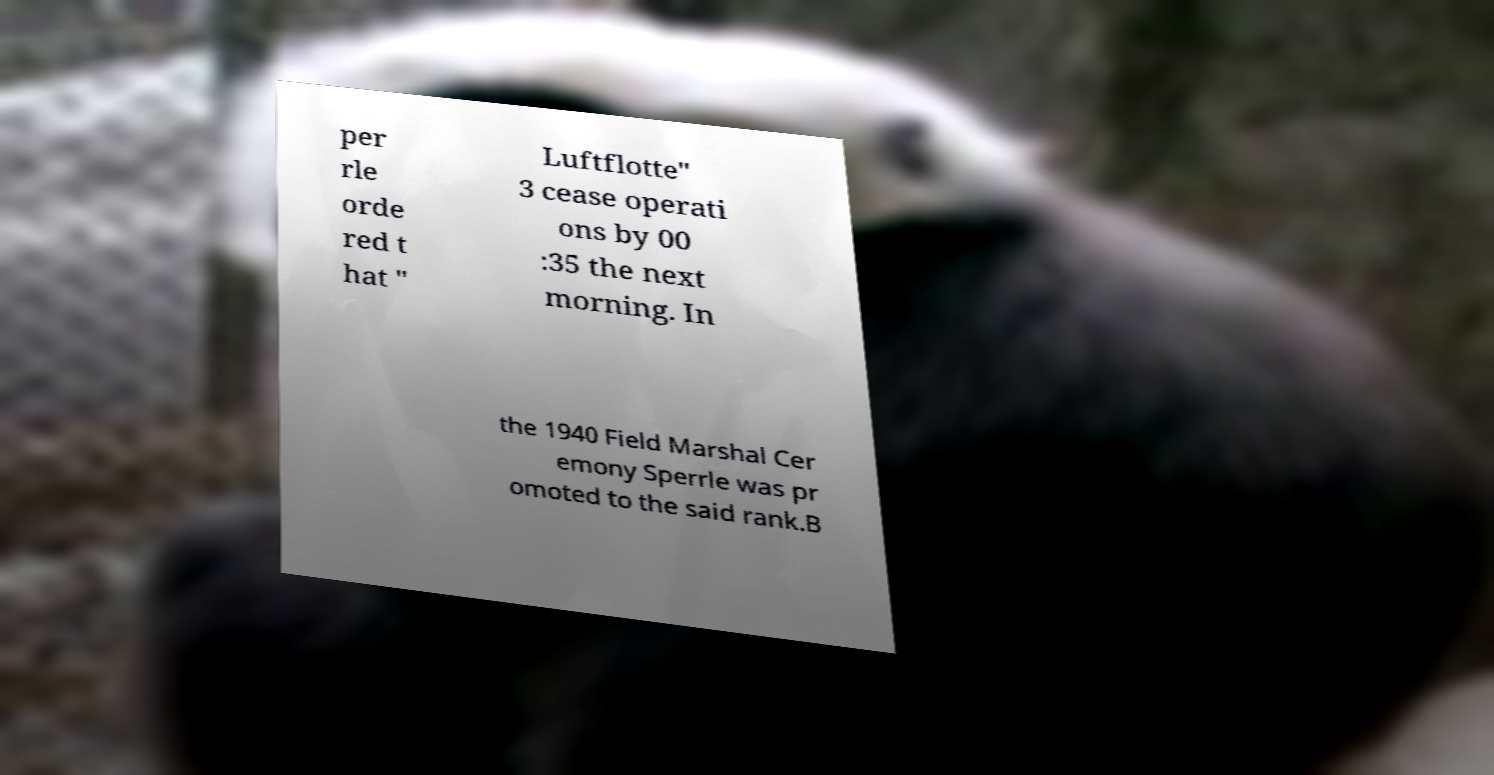Please read and relay the text visible in this image. What does it say? per rle orde red t hat " Luftflotte" 3 cease operati ons by 00 :35 the next morning. In the 1940 Field Marshal Cer emony Sperrle was pr omoted to the said rank.B 